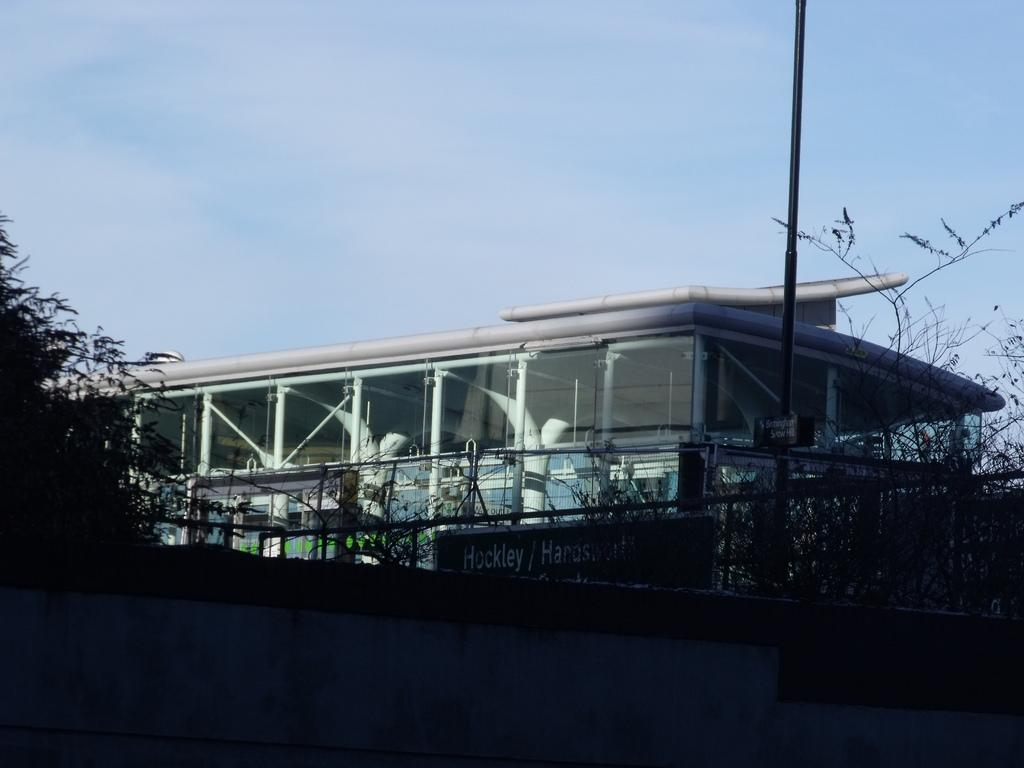What type of structure is present in the image? There is a building in the image. What else can be seen in the image besides the building? There is a pole, boards with text, a fence, plants, and the sky visible in the image. Can you describe the boards with text in the image? The boards with text are likely signs or advertisements. What type of vegetation is present in the image? There are plants in the image. Can you hear the credit being discussed in the image? There is no audio or conversation present in the image, so it is not possible to hear any discussion about credit. 